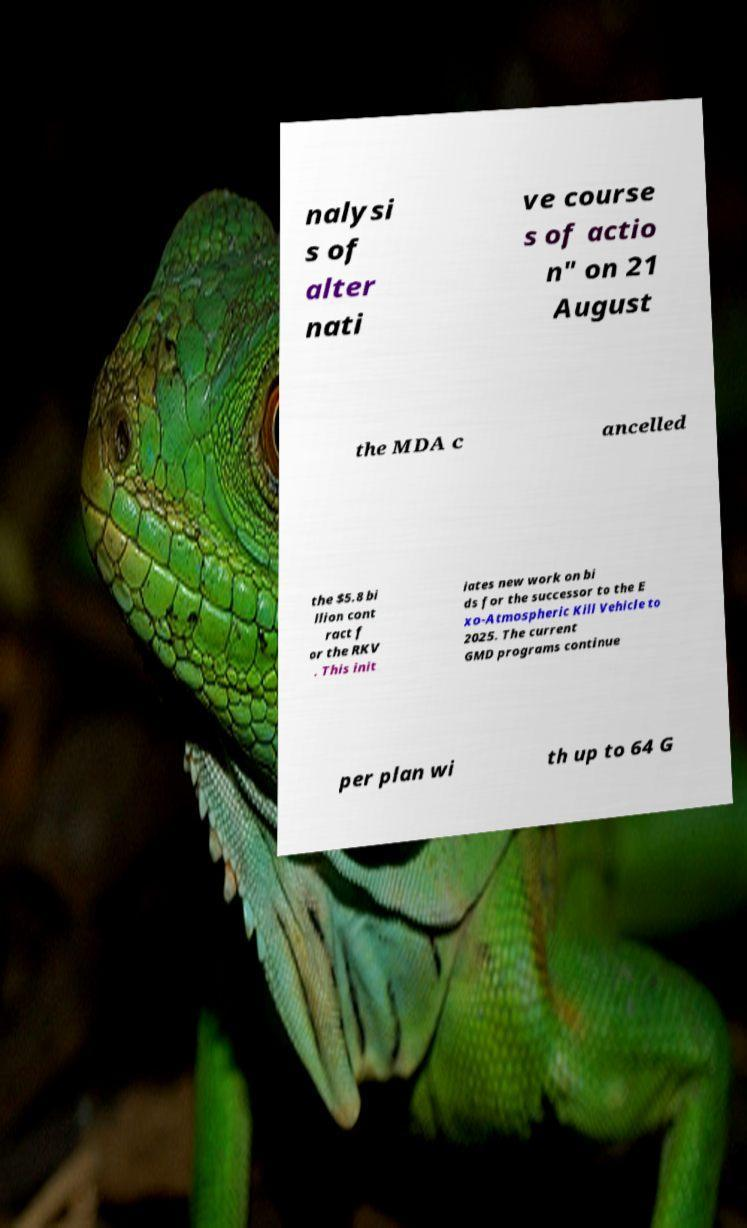Can you accurately transcribe the text from the provided image for me? nalysi s of alter nati ve course s of actio n" on 21 August the MDA c ancelled the $5.8 bi llion cont ract f or the RKV . This init iates new work on bi ds for the successor to the E xo-Atmospheric Kill Vehicle to 2025. The current GMD programs continue per plan wi th up to 64 G 